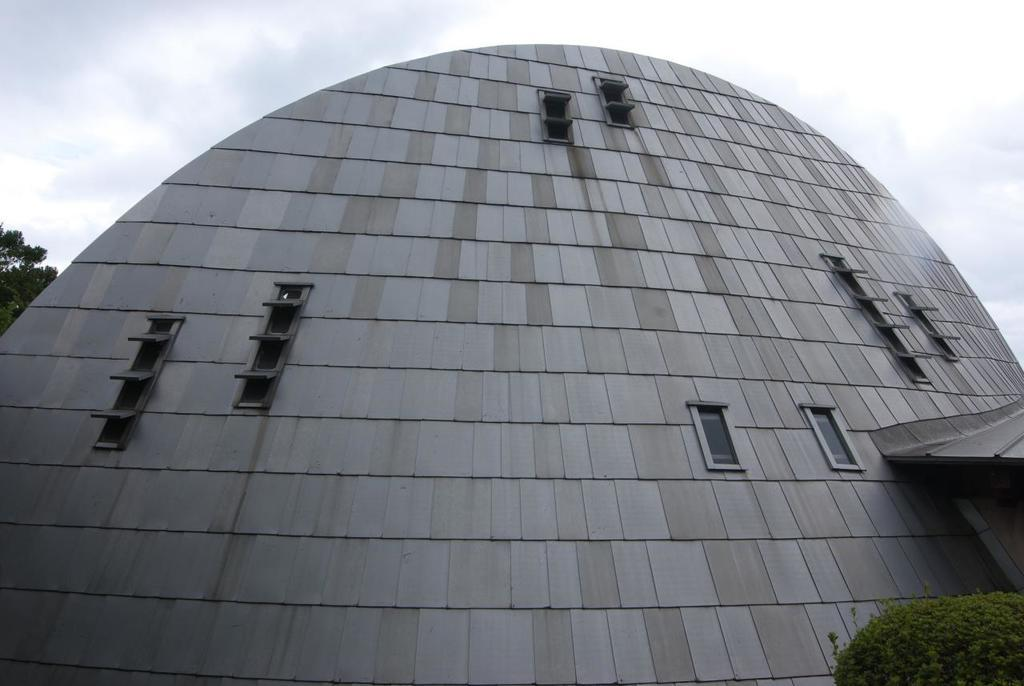What type of structure is present in the image? There is a building in the image. What feature of the building is mentioned in the facts? The building has windows. What else can be seen in the image besides the building? There are plants in the image. What is visible in the background of the image? The background of the image includes leaves and the sky. What type of screw can be seen holding the building together in the image? There is no screw visible in the image, as it is focused on the building, plants, and background. 